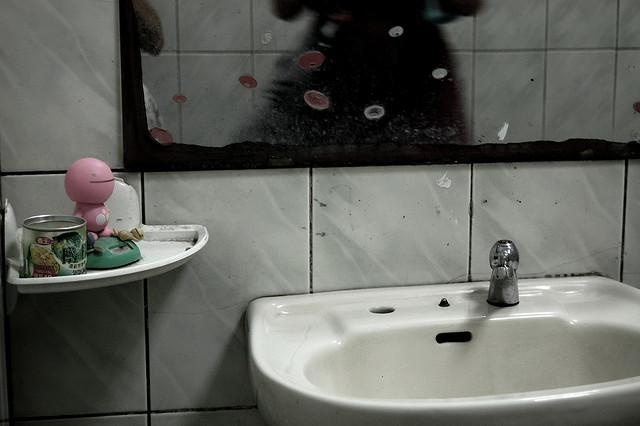What is the sink made out of?
Quick response, please. Porcelain. Are the tiles dirty?
Be succinct. Yes. Why is there no left faucet?
Short answer required. Broke. 